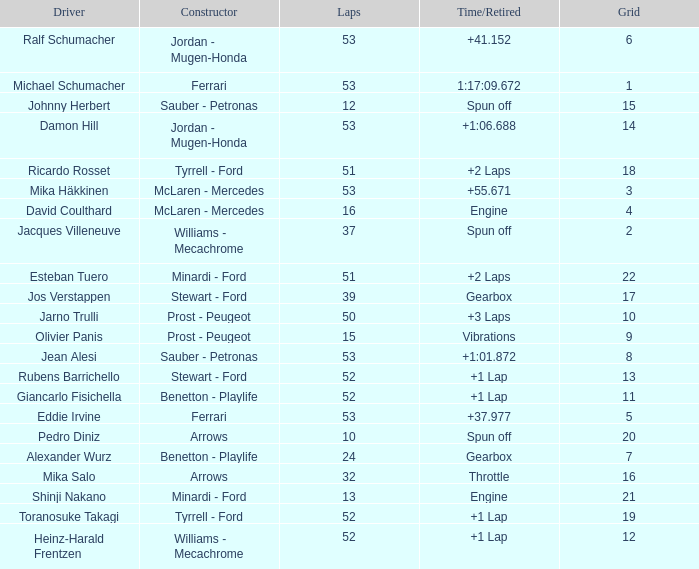What is the high lap total for pedro diniz? 10.0. 